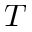Convert formula to latex. <formula><loc_0><loc_0><loc_500><loc_500>T</formula> 